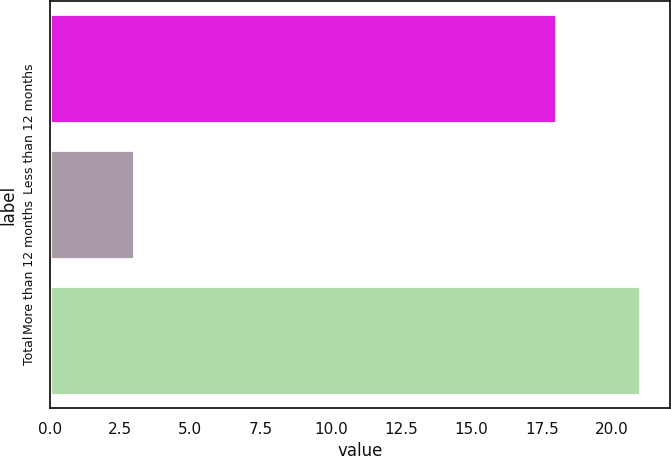<chart> <loc_0><loc_0><loc_500><loc_500><bar_chart><fcel>Less than 12 months<fcel>More than 12 months<fcel>Total<nl><fcel>18<fcel>3<fcel>21<nl></chart> 